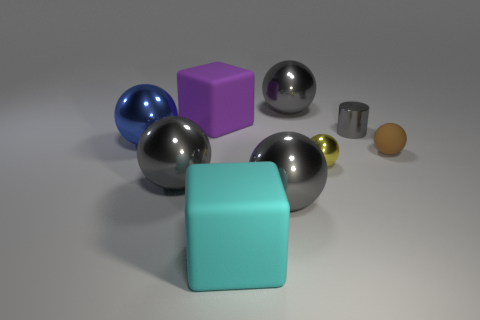What is the material of the big cyan cube?
Your answer should be compact. Rubber. Is there any other thing that has the same size as the purple rubber object?
Offer a terse response. Yes. What is the size of the cyan thing that is the same shape as the purple matte thing?
Offer a terse response. Large. Are there any big objects that are behind the rubber thing to the right of the small gray cylinder?
Provide a short and direct response. Yes. Does the tiny metal cylinder have the same color as the small matte ball?
Make the answer very short. No. What number of other objects are there of the same shape as the blue thing?
Provide a short and direct response. 5. Are there more rubber blocks that are on the right side of the cylinder than matte balls that are on the left side of the blue ball?
Make the answer very short. No. Is the size of the matte object that is in front of the small rubber sphere the same as the rubber block behind the blue object?
Your answer should be compact. Yes. The tiny brown thing has what shape?
Offer a very short reply. Sphere. There is a small object that is the same material as the small cylinder; what color is it?
Your answer should be compact. Yellow. 